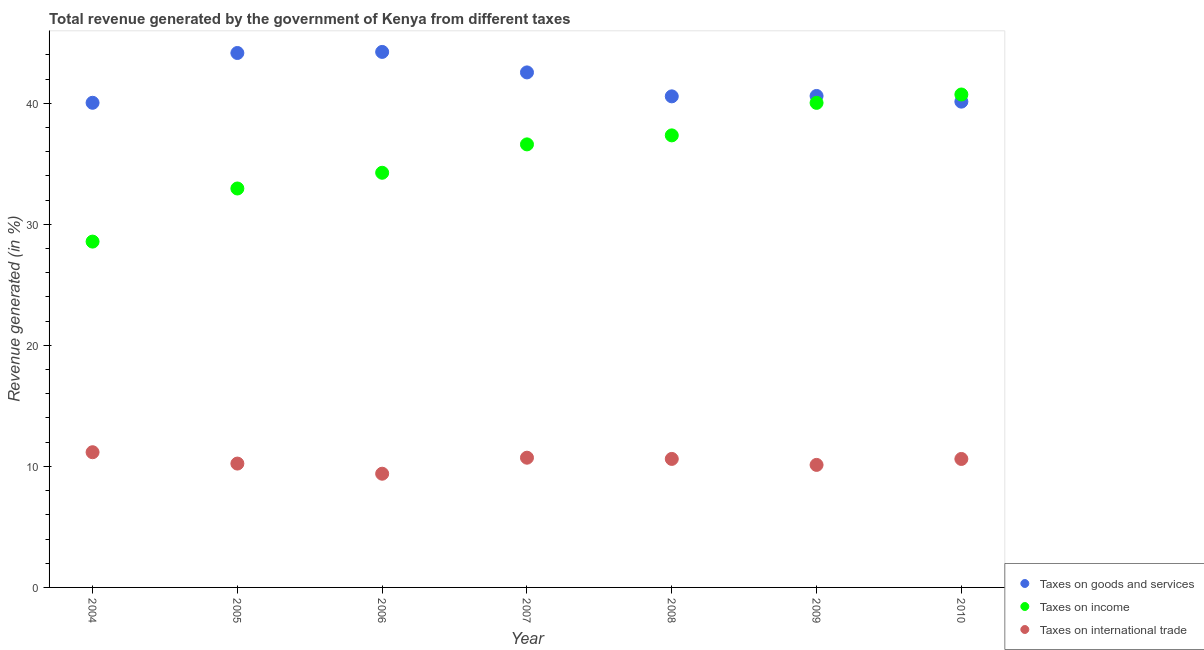Is the number of dotlines equal to the number of legend labels?
Offer a terse response. Yes. What is the percentage of revenue generated by taxes on goods and services in 2008?
Give a very brief answer. 40.57. Across all years, what is the maximum percentage of revenue generated by taxes on goods and services?
Your answer should be very brief. 44.25. Across all years, what is the minimum percentage of revenue generated by taxes on goods and services?
Make the answer very short. 40.04. In which year was the percentage of revenue generated by taxes on goods and services maximum?
Give a very brief answer. 2006. What is the total percentage of revenue generated by taxes on income in the graph?
Ensure brevity in your answer.  250.52. What is the difference between the percentage of revenue generated by taxes on income in 2007 and that in 2009?
Offer a terse response. -3.43. What is the difference between the percentage of revenue generated by tax on international trade in 2006 and the percentage of revenue generated by taxes on income in 2005?
Keep it short and to the point. -23.57. What is the average percentage of revenue generated by taxes on income per year?
Your answer should be compact. 35.79. In the year 2007, what is the difference between the percentage of revenue generated by taxes on goods and services and percentage of revenue generated by taxes on income?
Offer a terse response. 5.95. In how many years, is the percentage of revenue generated by taxes on goods and services greater than 28 %?
Your answer should be compact. 7. What is the ratio of the percentage of revenue generated by tax on international trade in 2006 to that in 2008?
Ensure brevity in your answer.  0.88. What is the difference between the highest and the second highest percentage of revenue generated by taxes on goods and services?
Make the answer very short. 0.09. What is the difference between the highest and the lowest percentage of revenue generated by tax on international trade?
Ensure brevity in your answer.  1.78. In how many years, is the percentage of revenue generated by tax on international trade greater than the average percentage of revenue generated by tax on international trade taken over all years?
Your answer should be very brief. 4. Is it the case that in every year, the sum of the percentage of revenue generated by taxes on goods and services and percentage of revenue generated by taxes on income is greater than the percentage of revenue generated by tax on international trade?
Provide a short and direct response. Yes. How many years are there in the graph?
Offer a terse response. 7. What is the difference between two consecutive major ticks on the Y-axis?
Make the answer very short. 10. Are the values on the major ticks of Y-axis written in scientific E-notation?
Give a very brief answer. No. What is the title of the graph?
Provide a short and direct response. Total revenue generated by the government of Kenya from different taxes. What is the label or title of the Y-axis?
Ensure brevity in your answer.  Revenue generated (in %). What is the Revenue generated (in %) of Taxes on goods and services in 2004?
Your answer should be very brief. 40.04. What is the Revenue generated (in %) of Taxes on income in 2004?
Give a very brief answer. 28.57. What is the Revenue generated (in %) in Taxes on international trade in 2004?
Make the answer very short. 11.17. What is the Revenue generated (in %) in Taxes on goods and services in 2005?
Your answer should be very brief. 44.16. What is the Revenue generated (in %) of Taxes on income in 2005?
Give a very brief answer. 32.96. What is the Revenue generated (in %) in Taxes on international trade in 2005?
Offer a terse response. 10.23. What is the Revenue generated (in %) of Taxes on goods and services in 2006?
Offer a very short reply. 44.25. What is the Revenue generated (in %) in Taxes on income in 2006?
Ensure brevity in your answer.  34.26. What is the Revenue generated (in %) of Taxes on international trade in 2006?
Your response must be concise. 9.39. What is the Revenue generated (in %) of Taxes on goods and services in 2007?
Ensure brevity in your answer.  42.55. What is the Revenue generated (in %) in Taxes on income in 2007?
Offer a terse response. 36.61. What is the Revenue generated (in %) in Taxes on international trade in 2007?
Offer a terse response. 10.72. What is the Revenue generated (in %) in Taxes on goods and services in 2008?
Keep it short and to the point. 40.57. What is the Revenue generated (in %) in Taxes on income in 2008?
Your answer should be very brief. 37.35. What is the Revenue generated (in %) in Taxes on international trade in 2008?
Give a very brief answer. 10.62. What is the Revenue generated (in %) in Taxes on goods and services in 2009?
Your response must be concise. 40.61. What is the Revenue generated (in %) in Taxes on income in 2009?
Ensure brevity in your answer.  40.04. What is the Revenue generated (in %) in Taxes on international trade in 2009?
Ensure brevity in your answer.  10.12. What is the Revenue generated (in %) in Taxes on goods and services in 2010?
Your answer should be very brief. 40.14. What is the Revenue generated (in %) in Taxes on income in 2010?
Provide a short and direct response. 40.73. What is the Revenue generated (in %) of Taxes on international trade in 2010?
Offer a terse response. 10.61. Across all years, what is the maximum Revenue generated (in %) in Taxes on goods and services?
Give a very brief answer. 44.25. Across all years, what is the maximum Revenue generated (in %) of Taxes on income?
Provide a short and direct response. 40.73. Across all years, what is the maximum Revenue generated (in %) in Taxes on international trade?
Make the answer very short. 11.17. Across all years, what is the minimum Revenue generated (in %) in Taxes on goods and services?
Offer a very short reply. 40.04. Across all years, what is the minimum Revenue generated (in %) in Taxes on income?
Your answer should be very brief. 28.57. Across all years, what is the minimum Revenue generated (in %) of Taxes on international trade?
Ensure brevity in your answer.  9.39. What is the total Revenue generated (in %) in Taxes on goods and services in the graph?
Your response must be concise. 292.32. What is the total Revenue generated (in %) in Taxes on income in the graph?
Your answer should be compact. 250.52. What is the total Revenue generated (in %) in Taxes on international trade in the graph?
Your response must be concise. 72.87. What is the difference between the Revenue generated (in %) in Taxes on goods and services in 2004 and that in 2005?
Provide a short and direct response. -4.11. What is the difference between the Revenue generated (in %) in Taxes on income in 2004 and that in 2005?
Offer a terse response. -4.39. What is the difference between the Revenue generated (in %) in Taxes on international trade in 2004 and that in 2005?
Ensure brevity in your answer.  0.94. What is the difference between the Revenue generated (in %) in Taxes on goods and services in 2004 and that in 2006?
Your response must be concise. -4.2. What is the difference between the Revenue generated (in %) in Taxes on income in 2004 and that in 2006?
Ensure brevity in your answer.  -5.69. What is the difference between the Revenue generated (in %) of Taxes on international trade in 2004 and that in 2006?
Give a very brief answer. 1.78. What is the difference between the Revenue generated (in %) in Taxes on goods and services in 2004 and that in 2007?
Offer a very short reply. -2.51. What is the difference between the Revenue generated (in %) of Taxes on income in 2004 and that in 2007?
Ensure brevity in your answer.  -8.03. What is the difference between the Revenue generated (in %) of Taxes on international trade in 2004 and that in 2007?
Give a very brief answer. 0.45. What is the difference between the Revenue generated (in %) of Taxes on goods and services in 2004 and that in 2008?
Provide a succinct answer. -0.53. What is the difference between the Revenue generated (in %) in Taxes on income in 2004 and that in 2008?
Offer a very short reply. -8.78. What is the difference between the Revenue generated (in %) of Taxes on international trade in 2004 and that in 2008?
Offer a very short reply. 0.55. What is the difference between the Revenue generated (in %) in Taxes on goods and services in 2004 and that in 2009?
Your response must be concise. -0.56. What is the difference between the Revenue generated (in %) in Taxes on income in 2004 and that in 2009?
Your answer should be very brief. -11.46. What is the difference between the Revenue generated (in %) in Taxes on international trade in 2004 and that in 2009?
Give a very brief answer. 1.05. What is the difference between the Revenue generated (in %) in Taxes on goods and services in 2004 and that in 2010?
Offer a terse response. -0.09. What is the difference between the Revenue generated (in %) in Taxes on income in 2004 and that in 2010?
Provide a succinct answer. -12.16. What is the difference between the Revenue generated (in %) of Taxes on international trade in 2004 and that in 2010?
Give a very brief answer. 0.56. What is the difference between the Revenue generated (in %) in Taxes on goods and services in 2005 and that in 2006?
Give a very brief answer. -0.09. What is the difference between the Revenue generated (in %) of Taxes on income in 2005 and that in 2006?
Make the answer very short. -1.3. What is the difference between the Revenue generated (in %) of Taxes on international trade in 2005 and that in 2006?
Provide a succinct answer. 0.84. What is the difference between the Revenue generated (in %) of Taxes on goods and services in 2005 and that in 2007?
Ensure brevity in your answer.  1.6. What is the difference between the Revenue generated (in %) in Taxes on income in 2005 and that in 2007?
Your answer should be compact. -3.64. What is the difference between the Revenue generated (in %) in Taxes on international trade in 2005 and that in 2007?
Offer a very short reply. -0.49. What is the difference between the Revenue generated (in %) of Taxes on goods and services in 2005 and that in 2008?
Give a very brief answer. 3.58. What is the difference between the Revenue generated (in %) in Taxes on income in 2005 and that in 2008?
Provide a short and direct response. -4.39. What is the difference between the Revenue generated (in %) in Taxes on international trade in 2005 and that in 2008?
Provide a short and direct response. -0.38. What is the difference between the Revenue generated (in %) in Taxes on goods and services in 2005 and that in 2009?
Ensure brevity in your answer.  3.55. What is the difference between the Revenue generated (in %) of Taxes on income in 2005 and that in 2009?
Your response must be concise. -7.08. What is the difference between the Revenue generated (in %) in Taxes on international trade in 2005 and that in 2009?
Give a very brief answer. 0.11. What is the difference between the Revenue generated (in %) in Taxes on goods and services in 2005 and that in 2010?
Keep it short and to the point. 4.02. What is the difference between the Revenue generated (in %) of Taxes on income in 2005 and that in 2010?
Make the answer very short. -7.77. What is the difference between the Revenue generated (in %) in Taxes on international trade in 2005 and that in 2010?
Your answer should be compact. -0.38. What is the difference between the Revenue generated (in %) of Taxes on goods and services in 2006 and that in 2007?
Provide a succinct answer. 1.69. What is the difference between the Revenue generated (in %) of Taxes on income in 2006 and that in 2007?
Provide a short and direct response. -2.35. What is the difference between the Revenue generated (in %) in Taxes on international trade in 2006 and that in 2007?
Your answer should be compact. -1.32. What is the difference between the Revenue generated (in %) of Taxes on goods and services in 2006 and that in 2008?
Offer a terse response. 3.67. What is the difference between the Revenue generated (in %) in Taxes on income in 2006 and that in 2008?
Your answer should be compact. -3.09. What is the difference between the Revenue generated (in %) of Taxes on international trade in 2006 and that in 2008?
Offer a very short reply. -1.22. What is the difference between the Revenue generated (in %) of Taxes on goods and services in 2006 and that in 2009?
Make the answer very short. 3.64. What is the difference between the Revenue generated (in %) in Taxes on income in 2006 and that in 2009?
Offer a very short reply. -5.78. What is the difference between the Revenue generated (in %) in Taxes on international trade in 2006 and that in 2009?
Give a very brief answer. -0.73. What is the difference between the Revenue generated (in %) of Taxes on goods and services in 2006 and that in 2010?
Provide a short and direct response. 4.11. What is the difference between the Revenue generated (in %) of Taxes on income in 2006 and that in 2010?
Keep it short and to the point. -6.47. What is the difference between the Revenue generated (in %) of Taxes on international trade in 2006 and that in 2010?
Your response must be concise. -1.22. What is the difference between the Revenue generated (in %) of Taxes on goods and services in 2007 and that in 2008?
Give a very brief answer. 1.98. What is the difference between the Revenue generated (in %) in Taxes on income in 2007 and that in 2008?
Offer a terse response. -0.74. What is the difference between the Revenue generated (in %) of Taxes on international trade in 2007 and that in 2008?
Give a very brief answer. 0.1. What is the difference between the Revenue generated (in %) in Taxes on goods and services in 2007 and that in 2009?
Your answer should be very brief. 1.95. What is the difference between the Revenue generated (in %) of Taxes on income in 2007 and that in 2009?
Offer a very short reply. -3.43. What is the difference between the Revenue generated (in %) of Taxes on international trade in 2007 and that in 2009?
Your answer should be compact. 0.59. What is the difference between the Revenue generated (in %) in Taxes on goods and services in 2007 and that in 2010?
Ensure brevity in your answer.  2.42. What is the difference between the Revenue generated (in %) in Taxes on income in 2007 and that in 2010?
Give a very brief answer. -4.12. What is the difference between the Revenue generated (in %) in Taxes on international trade in 2007 and that in 2010?
Keep it short and to the point. 0.1. What is the difference between the Revenue generated (in %) in Taxes on goods and services in 2008 and that in 2009?
Provide a succinct answer. -0.03. What is the difference between the Revenue generated (in %) of Taxes on income in 2008 and that in 2009?
Offer a very short reply. -2.69. What is the difference between the Revenue generated (in %) in Taxes on international trade in 2008 and that in 2009?
Provide a succinct answer. 0.49. What is the difference between the Revenue generated (in %) of Taxes on goods and services in 2008 and that in 2010?
Your response must be concise. 0.44. What is the difference between the Revenue generated (in %) of Taxes on income in 2008 and that in 2010?
Your answer should be very brief. -3.38. What is the difference between the Revenue generated (in %) of Taxes on international trade in 2008 and that in 2010?
Your response must be concise. 0. What is the difference between the Revenue generated (in %) of Taxes on goods and services in 2009 and that in 2010?
Your response must be concise. 0.47. What is the difference between the Revenue generated (in %) of Taxes on income in 2009 and that in 2010?
Your answer should be very brief. -0.69. What is the difference between the Revenue generated (in %) in Taxes on international trade in 2009 and that in 2010?
Your response must be concise. -0.49. What is the difference between the Revenue generated (in %) in Taxes on goods and services in 2004 and the Revenue generated (in %) in Taxes on income in 2005?
Ensure brevity in your answer.  7.08. What is the difference between the Revenue generated (in %) in Taxes on goods and services in 2004 and the Revenue generated (in %) in Taxes on international trade in 2005?
Offer a very short reply. 29.81. What is the difference between the Revenue generated (in %) in Taxes on income in 2004 and the Revenue generated (in %) in Taxes on international trade in 2005?
Offer a very short reply. 18.34. What is the difference between the Revenue generated (in %) of Taxes on goods and services in 2004 and the Revenue generated (in %) of Taxes on income in 2006?
Your answer should be compact. 5.78. What is the difference between the Revenue generated (in %) in Taxes on goods and services in 2004 and the Revenue generated (in %) in Taxes on international trade in 2006?
Make the answer very short. 30.65. What is the difference between the Revenue generated (in %) in Taxes on income in 2004 and the Revenue generated (in %) in Taxes on international trade in 2006?
Offer a terse response. 19.18. What is the difference between the Revenue generated (in %) in Taxes on goods and services in 2004 and the Revenue generated (in %) in Taxes on income in 2007?
Your answer should be very brief. 3.44. What is the difference between the Revenue generated (in %) in Taxes on goods and services in 2004 and the Revenue generated (in %) in Taxes on international trade in 2007?
Your answer should be compact. 29.32. What is the difference between the Revenue generated (in %) of Taxes on income in 2004 and the Revenue generated (in %) of Taxes on international trade in 2007?
Your answer should be very brief. 17.85. What is the difference between the Revenue generated (in %) of Taxes on goods and services in 2004 and the Revenue generated (in %) of Taxes on income in 2008?
Your answer should be compact. 2.69. What is the difference between the Revenue generated (in %) in Taxes on goods and services in 2004 and the Revenue generated (in %) in Taxes on international trade in 2008?
Offer a very short reply. 29.43. What is the difference between the Revenue generated (in %) in Taxes on income in 2004 and the Revenue generated (in %) in Taxes on international trade in 2008?
Your answer should be very brief. 17.96. What is the difference between the Revenue generated (in %) of Taxes on goods and services in 2004 and the Revenue generated (in %) of Taxes on income in 2009?
Give a very brief answer. 0.01. What is the difference between the Revenue generated (in %) of Taxes on goods and services in 2004 and the Revenue generated (in %) of Taxes on international trade in 2009?
Make the answer very short. 29.92. What is the difference between the Revenue generated (in %) in Taxes on income in 2004 and the Revenue generated (in %) in Taxes on international trade in 2009?
Your response must be concise. 18.45. What is the difference between the Revenue generated (in %) in Taxes on goods and services in 2004 and the Revenue generated (in %) in Taxes on income in 2010?
Your answer should be very brief. -0.69. What is the difference between the Revenue generated (in %) in Taxes on goods and services in 2004 and the Revenue generated (in %) in Taxes on international trade in 2010?
Your answer should be very brief. 29.43. What is the difference between the Revenue generated (in %) in Taxes on income in 2004 and the Revenue generated (in %) in Taxes on international trade in 2010?
Your answer should be very brief. 17.96. What is the difference between the Revenue generated (in %) in Taxes on goods and services in 2005 and the Revenue generated (in %) in Taxes on income in 2006?
Your answer should be compact. 9.9. What is the difference between the Revenue generated (in %) of Taxes on goods and services in 2005 and the Revenue generated (in %) of Taxes on international trade in 2006?
Offer a very short reply. 34.76. What is the difference between the Revenue generated (in %) in Taxes on income in 2005 and the Revenue generated (in %) in Taxes on international trade in 2006?
Make the answer very short. 23.57. What is the difference between the Revenue generated (in %) in Taxes on goods and services in 2005 and the Revenue generated (in %) in Taxes on income in 2007?
Your response must be concise. 7.55. What is the difference between the Revenue generated (in %) of Taxes on goods and services in 2005 and the Revenue generated (in %) of Taxes on international trade in 2007?
Keep it short and to the point. 33.44. What is the difference between the Revenue generated (in %) in Taxes on income in 2005 and the Revenue generated (in %) in Taxes on international trade in 2007?
Give a very brief answer. 22.24. What is the difference between the Revenue generated (in %) of Taxes on goods and services in 2005 and the Revenue generated (in %) of Taxes on income in 2008?
Offer a very short reply. 6.81. What is the difference between the Revenue generated (in %) of Taxes on goods and services in 2005 and the Revenue generated (in %) of Taxes on international trade in 2008?
Offer a very short reply. 33.54. What is the difference between the Revenue generated (in %) of Taxes on income in 2005 and the Revenue generated (in %) of Taxes on international trade in 2008?
Provide a short and direct response. 22.34. What is the difference between the Revenue generated (in %) in Taxes on goods and services in 2005 and the Revenue generated (in %) in Taxes on income in 2009?
Keep it short and to the point. 4.12. What is the difference between the Revenue generated (in %) of Taxes on goods and services in 2005 and the Revenue generated (in %) of Taxes on international trade in 2009?
Provide a succinct answer. 34.03. What is the difference between the Revenue generated (in %) of Taxes on income in 2005 and the Revenue generated (in %) of Taxes on international trade in 2009?
Your response must be concise. 22.84. What is the difference between the Revenue generated (in %) of Taxes on goods and services in 2005 and the Revenue generated (in %) of Taxes on income in 2010?
Give a very brief answer. 3.43. What is the difference between the Revenue generated (in %) of Taxes on goods and services in 2005 and the Revenue generated (in %) of Taxes on international trade in 2010?
Ensure brevity in your answer.  33.54. What is the difference between the Revenue generated (in %) in Taxes on income in 2005 and the Revenue generated (in %) in Taxes on international trade in 2010?
Ensure brevity in your answer.  22.35. What is the difference between the Revenue generated (in %) in Taxes on goods and services in 2006 and the Revenue generated (in %) in Taxes on income in 2007?
Give a very brief answer. 7.64. What is the difference between the Revenue generated (in %) in Taxes on goods and services in 2006 and the Revenue generated (in %) in Taxes on international trade in 2007?
Provide a succinct answer. 33.53. What is the difference between the Revenue generated (in %) in Taxes on income in 2006 and the Revenue generated (in %) in Taxes on international trade in 2007?
Offer a very short reply. 23.54. What is the difference between the Revenue generated (in %) of Taxes on goods and services in 2006 and the Revenue generated (in %) of Taxes on income in 2008?
Your response must be concise. 6.9. What is the difference between the Revenue generated (in %) in Taxes on goods and services in 2006 and the Revenue generated (in %) in Taxes on international trade in 2008?
Your response must be concise. 33.63. What is the difference between the Revenue generated (in %) of Taxes on income in 2006 and the Revenue generated (in %) of Taxes on international trade in 2008?
Ensure brevity in your answer.  23.64. What is the difference between the Revenue generated (in %) in Taxes on goods and services in 2006 and the Revenue generated (in %) in Taxes on income in 2009?
Give a very brief answer. 4.21. What is the difference between the Revenue generated (in %) in Taxes on goods and services in 2006 and the Revenue generated (in %) in Taxes on international trade in 2009?
Provide a short and direct response. 34.12. What is the difference between the Revenue generated (in %) of Taxes on income in 2006 and the Revenue generated (in %) of Taxes on international trade in 2009?
Keep it short and to the point. 24.14. What is the difference between the Revenue generated (in %) of Taxes on goods and services in 2006 and the Revenue generated (in %) of Taxes on income in 2010?
Your answer should be very brief. 3.52. What is the difference between the Revenue generated (in %) in Taxes on goods and services in 2006 and the Revenue generated (in %) in Taxes on international trade in 2010?
Provide a succinct answer. 33.63. What is the difference between the Revenue generated (in %) in Taxes on income in 2006 and the Revenue generated (in %) in Taxes on international trade in 2010?
Provide a succinct answer. 23.65. What is the difference between the Revenue generated (in %) of Taxes on goods and services in 2007 and the Revenue generated (in %) of Taxes on income in 2008?
Offer a terse response. 5.2. What is the difference between the Revenue generated (in %) in Taxes on goods and services in 2007 and the Revenue generated (in %) in Taxes on international trade in 2008?
Make the answer very short. 31.94. What is the difference between the Revenue generated (in %) in Taxes on income in 2007 and the Revenue generated (in %) in Taxes on international trade in 2008?
Offer a very short reply. 25.99. What is the difference between the Revenue generated (in %) of Taxes on goods and services in 2007 and the Revenue generated (in %) of Taxes on income in 2009?
Provide a succinct answer. 2.52. What is the difference between the Revenue generated (in %) of Taxes on goods and services in 2007 and the Revenue generated (in %) of Taxes on international trade in 2009?
Provide a short and direct response. 32.43. What is the difference between the Revenue generated (in %) in Taxes on income in 2007 and the Revenue generated (in %) in Taxes on international trade in 2009?
Offer a terse response. 26.48. What is the difference between the Revenue generated (in %) in Taxes on goods and services in 2007 and the Revenue generated (in %) in Taxes on income in 2010?
Your answer should be compact. 1.82. What is the difference between the Revenue generated (in %) in Taxes on goods and services in 2007 and the Revenue generated (in %) in Taxes on international trade in 2010?
Offer a terse response. 31.94. What is the difference between the Revenue generated (in %) in Taxes on income in 2007 and the Revenue generated (in %) in Taxes on international trade in 2010?
Make the answer very short. 25.99. What is the difference between the Revenue generated (in %) in Taxes on goods and services in 2008 and the Revenue generated (in %) in Taxes on income in 2009?
Your answer should be very brief. 0.54. What is the difference between the Revenue generated (in %) of Taxes on goods and services in 2008 and the Revenue generated (in %) of Taxes on international trade in 2009?
Provide a short and direct response. 30.45. What is the difference between the Revenue generated (in %) of Taxes on income in 2008 and the Revenue generated (in %) of Taxes on international trade in 2009?
Offer a terse response. 27.23. What is the difference between the Revenue generated (in %) in Taxes on goods and services in 2008 and the Revenue generated (in %) in Taxes on income in 2010?
Your response must be concise. -0.15. What is the difference between the Revenue generated (in %) in Taxes on goods and services in 2008 and the Revenue generated (in %) in Taxes on international trade in 2010?
Offer a very short reply. 29.96. What is the difference between the Revenue generated (in %) of Taxes on income in 2008 and the Revenue generated (in %) of Taxes on international trade in 2010?
Your answer should be very brief. 26.74. What is the difference between the Revenue generated (in %) in Taxes on goods and services in 2009 and the Revenue generated (in %) in Taxes on income in 2010?
Ensure brevity in your answer.  -0.12. What is the difference between the Revenue generated (in %) of Taxes on goods and services in 2009 and the Revenue generated (in %) of Taxes on international trade in 2010?
Keep it short and to the point. 29.99. What is the difference between the Revenue generated (in %) of Taxes on income in 2009 and the Revenue generated (in %) of Taxes on international trade in 2010?
Keep it short and to the point. 29.42. What is the average Revenue generated (in %) of Taxes on goods and services per year?
Your response must be concise. 41.76. What is the average Revenue generated (in %) in Taxes on income per year?
Your answer should be compact. 35.79. What is the average Revenue generated (in %) of Taxes on international trade per year?
Keep it short and to the point. 10.41. In the year 2004, what is the difference between the Revenue generated (in %) of Taxes on goods and services and Revenue generated (in %) of Taxes on income?
Your response must be concise. 11.47. In the year 2004, what is the difference between the Revenue generated (in %) of Taxes on goods and services and Revenue generated (in %) of Taxes on international trade?
Give a very brief answer. 28.87. In the year 2004, what is the difference between the Revenue generated (in %) in Taxes on income and Revenue generated (in %) in Taxes on international trade?
Give a very brief answer. 17.4. In the year 2005, what is the difference between the Revenue generated (in %) in Taxes on goods and services and Revenue generated (in %) in Taxes on income?
Provide a succinct answer. 11.2. In the year 2005, what is the difference between the Revenue generated (in %) in Taxes on goods and services and Revenue generated (in %) in Taxes on international trade?
Your response must be concise. 33.92. In the year 2005, what is the difference between the Revenue generated (in %) in Taxes on income and Revenue generated (in %) in Taxes on international trade?
Your answer should be very brief. 22.73. In the year 2006, what is the difference between the Revenue generated (in %) of Taxes on goods and services and Revenue generated (in %) of Taxes on income?
Offer a terse response. 9.99. In the year 2006, what is the difference between the Revenue generated (in %) of Taxes on goods and services and Revenue generated (in %) of Taxes on international trade?
Keep it short and to the point. 34.85. In the year 2006, what is the difference between the Revenue generated (in %) of Taxes on income and Revenue generated (in %) of Taxes on international trade?
Provide a succinct answer. 24.87. In the year 2007, what is the difference between the Revenue generated (in %) of Taxes on goods and services and Revenue generated (in %) of Taxes on income?
Keep it short and to the point. 5.95. In the year 2007, what is the difference between the Revenue generated (in %) in Taxes on goods and services and Revenue generated (in %) in Taxes on international trade?
Ensure brevity in your answer.  31.83. In the year 2007, what is the difference between the Revenue generated (in %) of Taxes on income and Revenue generated (in %) of Taxes on international trade?
Provide a succinct answer. 25.89. In the year 2008, what is the difference between the Revenue generated (in %) of Taxes on goods and services and Revenue generated (in %) of Taxes on income?
Provide a short and direct response. 3.22. In the year 2008, what is the difference between the Revenue generated (in %) in Taxes on goods and services and Revenue generated (in %) in Taxes on international trade?
Ensure brevity in your answer.  29.96. In the year 2008, what is the difference between the Revenue generated (in %) in Taxes on income and Revenue generated (in %) in Taxes on international trade?
Your answer should be very brief. 26.73. In the year 2009, what is the difference between the Revenue generated (in %) of Taxes on goods and services and Revenue generated (in %) of Taxes on income?
Offer a terse response. 0.57. In the year 2009, what is the difference between the Revenue generated (in %) of Taxes on goods and services and Revenue generated (in %) of Taxes on international trade?
Offer a very short reply. 30.48. In the year 2009, what is the difference between the Revenue generated (in %) of Taxes on income and Revenue generated (in %) of Taxes on international trade?
Provide a succinct answer. 29.91. In the year 2010, what is the difference between the Revenue generated (in %) in Taxes on goods and services and Revenue generated (in %) in Taxes on income?
Your answer should be very brief. -0.59. In the year 2010, what is the difference between the Revenue generated (in %) in Taxes on goods and services and Revenue generated (in %) in Taxes on international trade?
Your answer should be very brief. 29.52. In the year 2010, what is the difference between the Revenue generated (in %) of Taxes on income and Revenue generated (in %) of Taxes on international trade?
Keep it short and to the point. 30.11. What is the ratio of the Revenue generated (in %) in Taxes on goods and services in 2004 to that in 2005?
Your response must be concise. 0.91. What is the ratio of the Revenue generated (in %) in Taxes on income in 2004 to that in 2005?
Provide a succinct answer. 0.87. What is the ratio of the Revenue generated (in %) in Taxes on international trade in 2004 to that in 2005?
Your answer should be very brief. 1.09. What is the ratio of the Revenue generated (in %) in Taxes on goods and services in 2004 to that in 2006?
Your response must be concise. 0.91. What is the ratio of the Revenue generated (in %) of Taxes on income in 2004 to that in 2006?
Make the answer very short. 0.83. What is the ratio of the Revenue generated (in %) of Taxes on international trade in 2004 to that in 2006?
Provide a succinct answer. 1.19. What is the ratio of the Revenue generated (in %) of Taxes on goods and services in 2004 to that in 2007?
Provide a short and direct response. 0.94. What is the ratio of the Revenue generated (in %) of Taxes on income in 2004 to that in 2007?
Provide a short and direct response. 0.78. What is the ratio of the Revenue generated (in %) in Taxes on international trade in 2004 to that in 2007?
Give a very brief answer. 1.04. What is the ratio of the Revenue generated (in %) of Taxes on goods and services in 2004 to that in 2008?
Give a very brief answer. 0.99. What is the ratio of the Revenue generated (in %) in Taxes on income in 2004 to that in 2008?
Make the answer very short. 0.77. What is the ratio of the Revenue generated (in %) in Taxes on international trade in 2004 to that in 2008?
Offer a terse response. 1.05. What is the ratio of the Revenue generated (in %) of Taxes on goods and services in 2004 to that in 2009?
Provide a succinct answer. 0.99. What is the ratio of the Revenue generated (in %) in Taxes on income in 2004 to that in 2009?
Give a very brief answer. 0.71. What is the ratio of the Revenue generated (in %) of Taxes on international trade in 2004 to that in 2009?
Offer a terse response. 1.1. What is the ratio of the Revenue generated (in %) of Taxes on income in 2004 to that in 2010?
Provide a short and direct response. 0.7. What is the ratio of the Revenue generated (in %) in Taxes on international trade in 2004 to that in 2010?
Provide a succinct answer. 1.05. What is the ratio of the Revenue generated (in %) in Taxes on income in 2005 to that in 2006?
Provide a short and direct response. 0.96. What is the ratio of the Revenue generated (in %) of Taxes on international trade in 2005 to that in 2006?
Provide a succinct answer. 1.09. What is the ratio of the Revenue generated (in %) of Taxes on goods and services in 2005 to that in 2007?
Your answer should be compact. 1.04. What is the ratio of the Revenue generated (in %) of Taxes on income in 2005 to that in 2007?
Keep it short and to the point. 0.9. What is the ratio of the Revenue generated (in %) in Taxes on international trade in 2005 to that in 2007?
Make the answer very short. 0.95. What is the ratio of the Revenue generated (in %) of Taxes on goods and services in 2005 to that in 2008?
Make the answer very short. 1.09. What is the ratio of the Revenue generated (in %) in Taxes on income in 2005 to that in 2008?
Provide a succinct answer. 0.88. What is the ratio of the Revenue generated (in %) of Taxes on international trade in 2005 to that in 2008?
Your answer should be very brief. 0.96. What is the ratio of the Revenue generated (in %) of Taxes on goods and services in 2005 to that in 2009?
Keep it short and to the point. 1.09. What is the ratio of the Revenue generated (in %) in Taxes on income in 2005 to that in 2009?
Provide a succinct answer. 0.82. What is the ratio of the Revenue generated (in %) of Taxes on international trade in 2005 to that in 2009?
Make the answer very short. 1.01. What is the ratio of the Revenue generated (in %) of Taxes on goods and services in 2005 to that in 2010?
Make the answer very short. 1.1. What is the ratio of the Revenue generated (in %) of Taxes on income in 2005 to that in 2010?
Give a very brief answer. 0.81. What is the ratio of the Revenue generated (in %) of Taxes on international trade in 2005 to that in 2010?
Ensure brevity in your answer.  0.96. What is the ratio of the Revenue generated (in %) of Taxes on goods and services in 2006 to that in 2007?
Provide a succinct answer. 1.04. What is the ratio of the Revenue generated (in %) in Taxes on income in 2006 to that in 2007?
Your answer should be very brief. 0.94. What is the ratio of the Revenue generated (in %) in Taxes on international trade in 2006 to that in 2007?
Provide a succinct answer. 0.88. What is the ratio of the Revenue generated (in %) of Taxes on goods and services in 2006 to that in 2008?
Offer a terse response. 1.09. What is the ratio of the Revenue generated (in %) in Taxes on income in 2006 to that in 2008?
Ensure brevity in your answer.  0.92. What is the ratio of the Revenue generated (in %) in Taxes on international trade in 2006 to that in 2008?
Your answer should be very brief. 0.88. What is the ratio of the Revenue generated (in %) of Taxes on goods and services in 2006 to that in 2009?
Provide a short and direct response. 1.09. What is the ratio of the Revenue generated (in %) in Taxes on income in 2006 to that in 2009?
Make the answer very short. 0.86. What is the ratio of the Revenue generated (in %) of Taxes on international trade in 2006 to that in 2009?
Your response must be concise. 0.93. What is the ratio of the Revenue generated (in %) in Taxes on goods and services in 2006 to that in 2010?
Offer a terse response. 1.1. What is the ratio of the Revenue generated (in %) of Taxes on income in 2006 to that in 2010?
Give a very brief answer. 0.84. What is the ratio of the Revenue generated (in %) of Taxes on international trade in 2006 to that in 2010?
Your answer should be very brief. 0.89. What is the ratio of the Revenue generated (in %) of Taxes on goods and services in 2007 to that in 2008?
Ensure brevity in your answer.  1.05. What is the ratio of the Revenue generated (in %) in Taxes on income in 2007 to that in 2008?
Your answer should be very brief. 0.98. What is the ratio of the Revenue generated (in %) of Taxes on international trade in 2007 to that in 2008?
Your answer should be compact. 1.01. What is the ratio of the Revenue generated (in %) in Taxes on goods and services in 2007 to that in 2009?
Provide a succinct answer. 1.05. What is the ratio of the Revenue generated (in %) of Taxes on income in 2007 to that in 2009?
Make the answer very short. 0.91. What is the ratio of the Revenue generated (in %) in Taxes on international trade in 2007 to that in 2009?
Offer a terse response. 1.06. What is the ratio of the Revenue generated (in %) of Taxes on goods and services in 2007 to that in 2010?
Your answer should be very brief. 1.06. What is the ratio of the Revenue generated (in %) of Taxes on income in 2007 to that in 2010?
Your answer should be compact. 0.9. What is the ratio of the Revenue generated (in %) in Taxes on international trade in 2007 to that in 2010?
Provide a succinct answer. 1.01. What is the ratio of the Revenue generated (in %) of Taxes on income in 2008 to that in 2009?
Offer a terse response. 0.93. What is the ratio of the Revenue generated (in %) of Taxes on international trade in 2008 to that in 2009?
Make the answer very short. 1.05. What is the ratio of the Revenue generated (in %) of Taxes on goods and services in 2008 to that in 2010?
Make the answer very short. 1.01. What is the ratio of the Revenue generated (in %) in Taxes on income in 2008 to that in 2010?
Ensure brevity in your answer.  0.92. What is the ratio of the Revenue generated (in %) of Taxes on goods and services in 2009 to that in 2010?
Offer a terse response. 1.01. What is the ratio of the Revenue generated (in %) in Taxes on international trade in 2009 to that in 2010?
Keep it short and to the point. 0.95. What is the difference between the highest and the second highest Revenue generated (in %) of Taxes on goods and services?
Provide a short and direct response. 0.09. What is the difference between the highest and the second highest Revenue generated (in %) in Taxes on income?
Offer a very short reply. 0.69. What is the difference between the highest and the second highest Revenue generated (in %) of Taxes on international trade?
Provide a short and direct response. 0.45. What is the difference between the highest and the lowest Revenue generated (in %) in Taxes on goods and services?
Keep it short and to the point. 4.2. What is the difference between the highest and the lowest Revenue generated (in %) in Taxes on income?
Your answer should be compact. 12.16. What is the difference between the highest and the lowest Revenue generated (in %) in Taxes on international trade?
Keep it short and to the point. 1.78. 